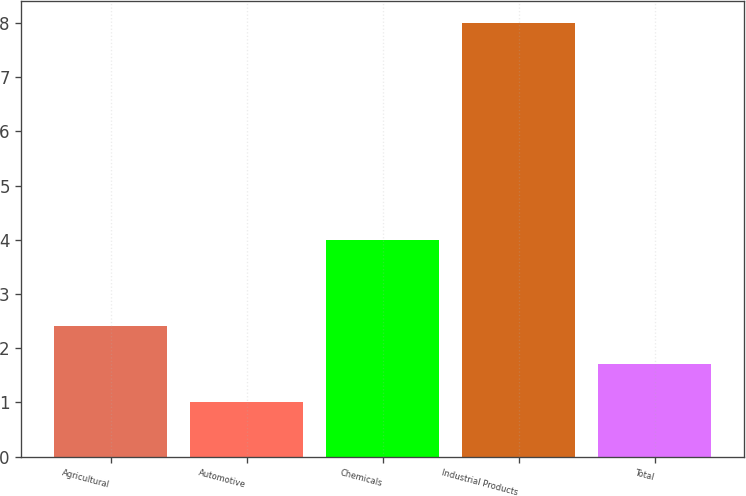<chart> <loc_0><loc_0><loc_500><loc_500><bar_chart><fcel>Agricultural<fcel>Automotive<fcel>Chemicals<fcel>Industrial Products<fcel>Total<nl><fcel>2.4<fcel>1<fcel>4<fcel>8<fcel>1.7<nl></chart> 